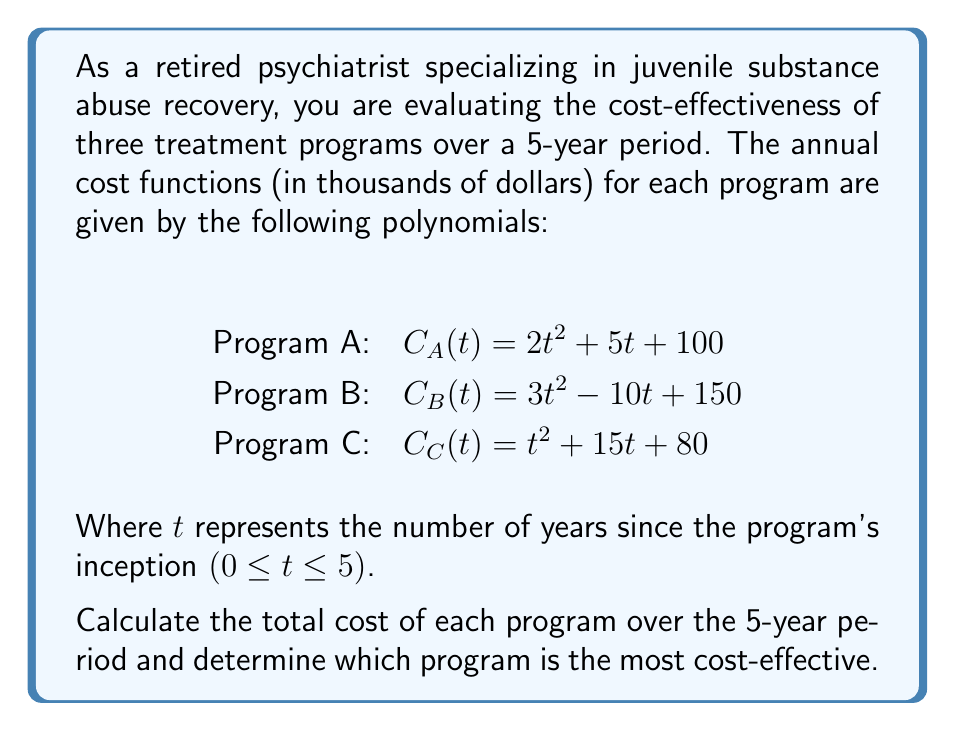Give your solution to this math problem. To solve this problem, we need to calculate the total cost of each program over the 5-year period by integrating the cost functions from $t=0$ to $t=5$. Then, we'll compare the results to determine the most cost-effective program.

1. For Program A:
   $$\int_0^5 (2t^2 + 5t + 100) dt = \left[\frac{2t^3}{3} + \frac{5t^2}{2} + 100t\right]_0^5$$
   $$= \left(\frac{2(125)}{3} + \frac{5(25)}{2} + 500\right) - (0 + 0 + 0)$$
   $$= 83.33 + 62.5 + 500 = 645.83$$

2. For Program B:
   $$\int_0^5 (3t^2 - 10t + 150) dt = \left[t^3 - 5t^2 + 150t\right]_0^5$$
   $$= (125 - 125 + 750) - (0 - 0 + 0) = 750$$

3. For Program C:
   $$\int_0^5 (t^2 + 15t + 80) dt = \left[\frac{t^3}{3} + \frac{15t^2}{2} + 80t\right]_0^5$$
   $$= \left(\frac{125}{3} + \frac{15(25)}{2} + 400\right) - (0 + 0 + 0)$$
   $$= 41.67 + 187.5 + 400 = 629.17$$

The total costs (in thousands of dollars) over the 5-year period are:
Program A: $645.83
Program B: $750.00
Program C: $629.17

Program C has the lowest total cost over the 5-year period, making it the most cost-effective option.
Answer: Program C is the most cost-effective, with a total cost of $629,170 over the 5-year period. 